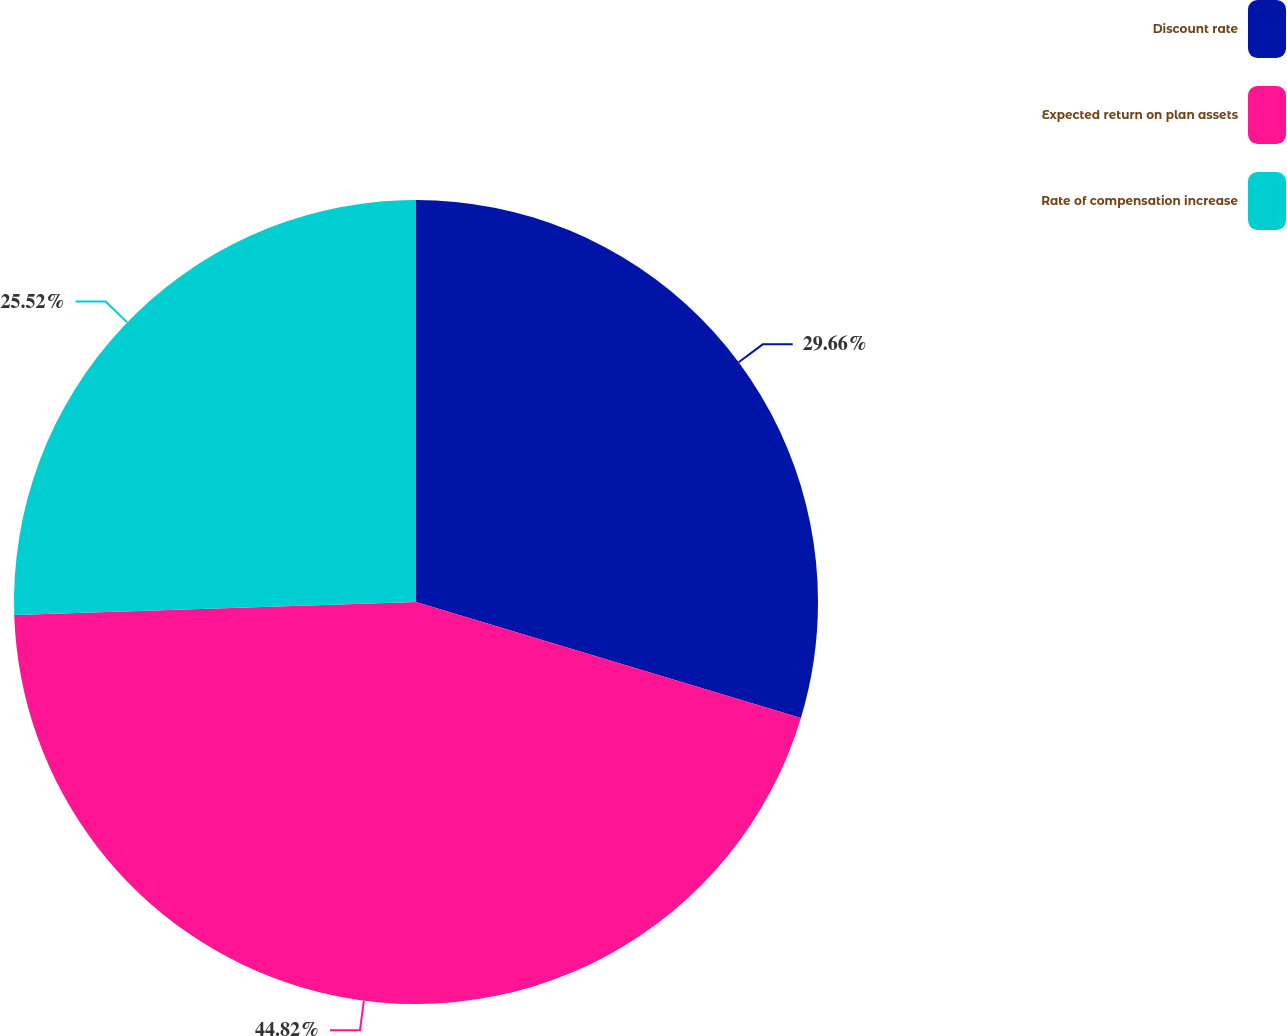Convert chart. <chart><loc_0><loc_0><loc_500><loc_500><pie_chart><fcel>Discount rate<fcel>Expected return on plan assets<fcel>Rate of compensation increase<nl><fcel>29.66%<fcel>44.83%<fcel>25.52%<nl></chart> 